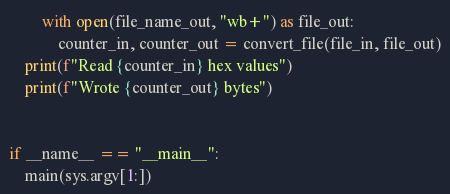<code> <loc_0><loc_0><loc_500><loc_500><_Python_>        with open(file_name_out, "wb+") as file_out:
            counter_in, counter_out = convert_file(file_in, file_out)
    print(f"Read {counter_in} hex values")
    print(f"Wrote {counter_out} bytes")


if __name__ == "__main__":
    main(sys.argv[1:])

</code> 